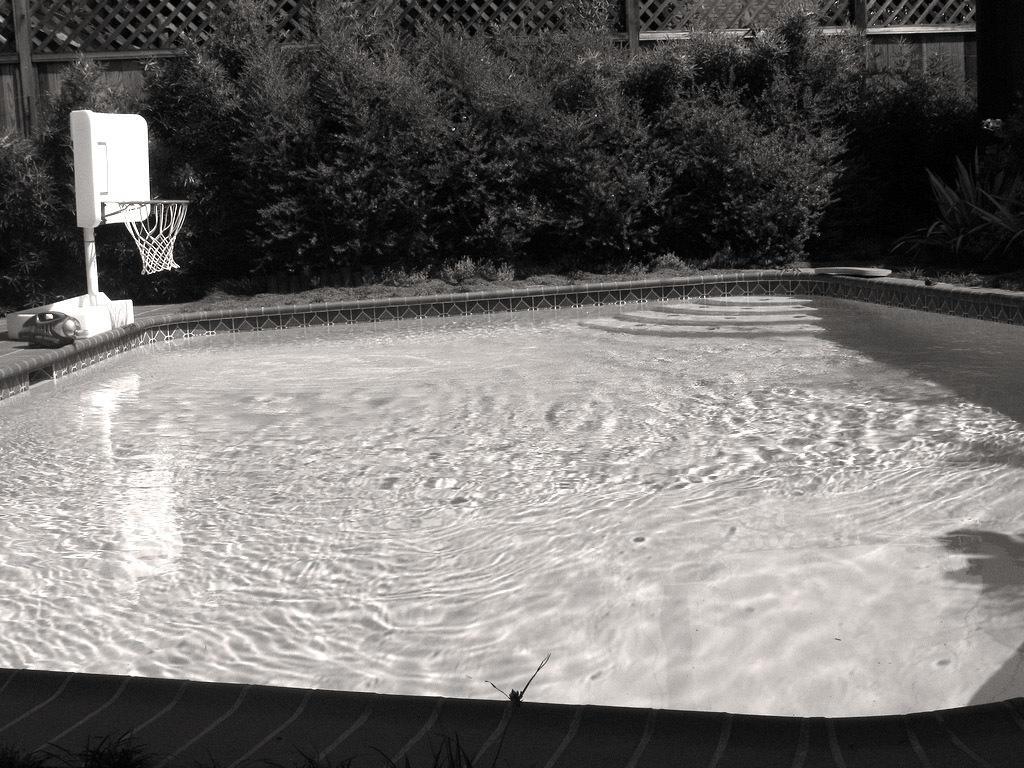Could you give a brief overview of what you see in this image? In the center of the image pool contains water. At the top of the image we can see volleyball court and object are there. In the background of the image we can see some plants and fencing are there. 